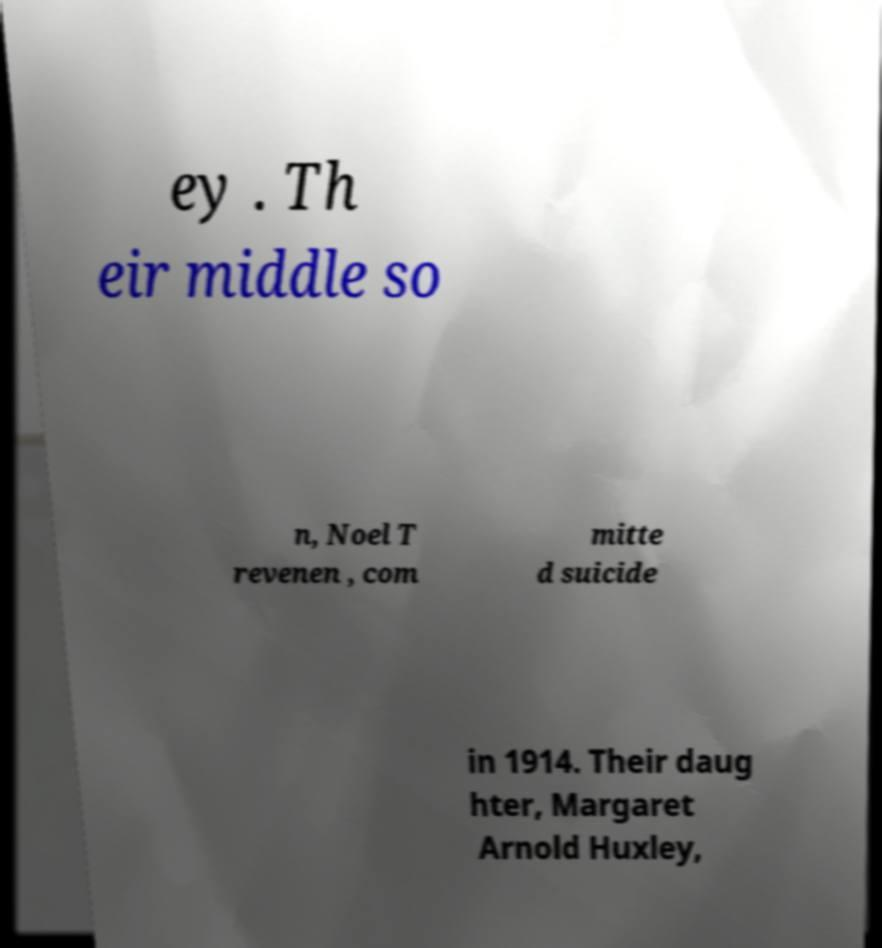Please read and relay the text visible in this image. What does it say? ey . Th eir middle so n, Noel T revenen , com mitte d suicide in 1914. Their daug hter, Margaret Arnold Huxley, 